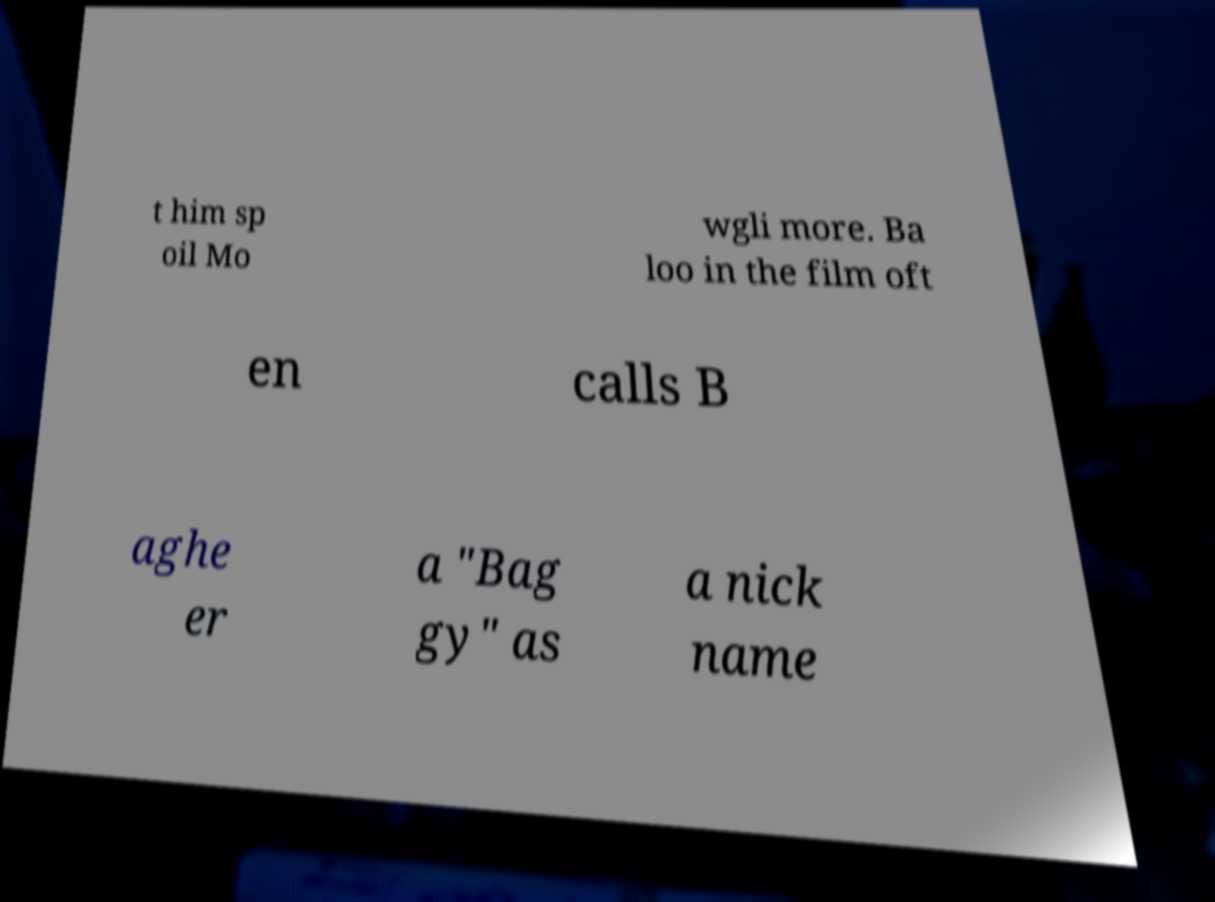Can you accurately transcribe the text from the provided image for me? t him sp oil Mo wgli more. Ba loo in the film oft en calls B aghe er a "Bag gy" as a nick name 